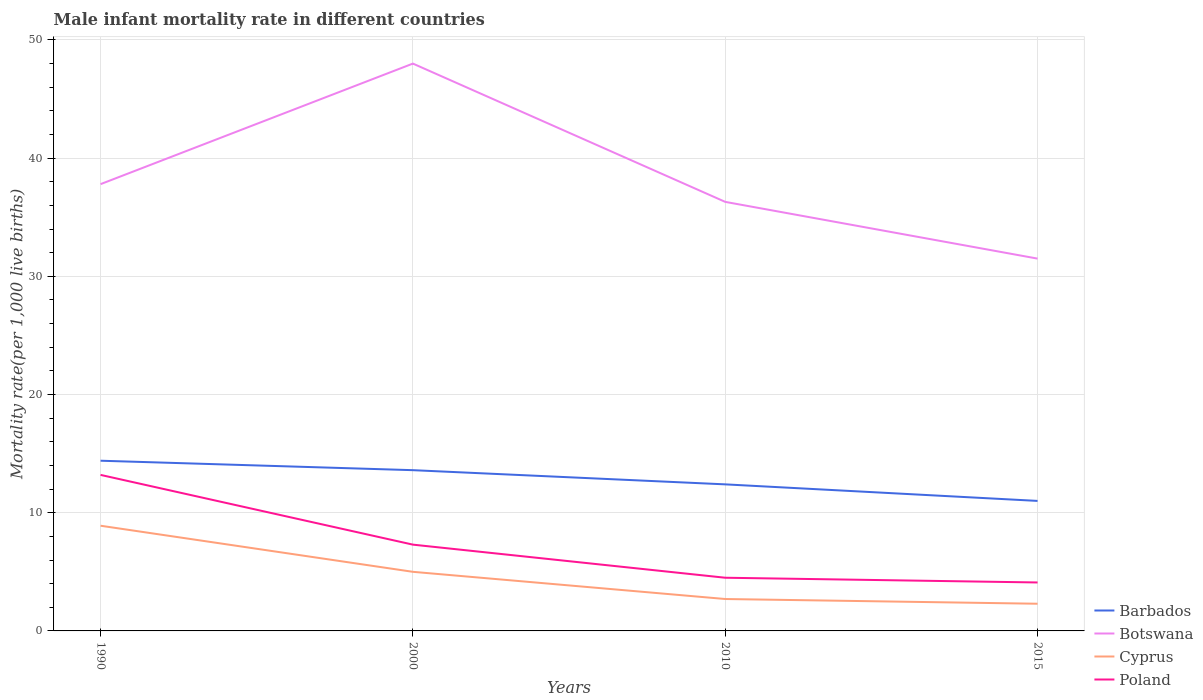How many different coloured lines are there?
Your answer should be very brief. 4. Is the number of lines equal to the number of legend labels?
Make the answer very short. Yes. In which year was the male infant mortality rate in Cyprus maximum?
Keep it short and to the point. 2015. What is the total male infant mortality rate in Botswana in the graph?
Provide a short and direct response. 16.5. How many lines are there?
Your answer should be very brief. 4. How many years are there in the graph?
Provide a short and direct response. 4. What is the difference between two consecutive major ticks on the Y-axis?
Your response must be concise. 10. Does the graph contain any zero values?
Your response must be concise. No. Where does the legend appear in the graph?
Your answer should be very brief. Bottom right. What is the title of the graph?
Your answer should be compact. Male infant mortality rate in different countries. What is the label or title of the Y-axis?
Offer a very short reply. Mortality rate(per 1,0 live births). What is the Mortality rate(per 1,000 live births) of Barbados in 1990?
Offer a very short reply. 14.4. What is the Mortality rate(per 1,000 live births) of Botswana in 1990?
Make the answer very short. 37.8. What is the Mortality rate(per 1,000 live births) in Poland in 1990?
Your answer should be very brief. 13.2. What is the Mortality rate(per 1,000 live births) in Barbados in 2010?
Make the answer very short. 12.4. What is the Mortality rate(per 1,000 live births) of Botswana in 2010?
Your response must be concise. 36.3. What is the Mortality rate(per 1,000 live births) in Cyprus in 2010?
Keep it short and to the point. 2.7. What is the Mortality rate(per 1,000 live births) in Barbados in 2015?
Provide a short and direct response. 11. What is the Mortality rate(per 1,000 live births) in Botswana in 2015?
Make the answer very short. 31.5. What is the Mortality rate(per 1,000 live births) in Cyprus in 2015?
Ensure brevity in your answer.  2.3. What is the Mortality rate(per 1,000 live births) of Poland in 2015?
Provide a short and direct response. 4.1. Across all years, what is the maximum Mortality rate(per 1,000 live births) of Barbados?
Provide a short and direct response. 14.4. Across all years, what is the maximum Mortality rate(per 1,000 live births) of Cyprus?
Provide a short and direct response. 8.9. Across all years, what is the minimum Mortality rate(per 1,000 live births) of Botswana?
Keep it short and to the point. 31.5. Across all years, what is the minimum Mortality rate(per 1,000 live births) of Poland?
Give a very brief answer. 4.1. What is the total Mortality rate(per 1,000 live births) of Barbados in the graph?
Your answer should be compact. 51.4. What is the total Mortality rate(per 1,000 live births) of Botswana in the graph?
Your answer should be very brief. 153.6. What is the total Mortality rate(per 1,000 live births) in Cyprus in the graph?
Your answer should be compact. 18.9. What is the total Mortality rate(per 1,000 live births) in Poland in the graph?
Keep it short and to the point. 29.1. What is the difference between the Mortality rate(per 1,000 live births) in Poland in 1990 and that in 2000?
Your response must be concise. 5.9. What is the difference between the Mortality rate(per 1,000 live births) of Botswana in 1990 and that in 2010?
Your answer should be compact. 1.5. What is the difference between the Mortality rate(per 1,000 live births) of Barbados in 1990 and that in 2015?
Ensure brevity in your answer.  3.4. What is the difference between the Mortality rate(per 1,000 live births) of Cyprus in 1990 and that in 2015?
Your response must be concise. 6.6. What is the difference between the Mortality rate(per 1,000 live births) in Poland in 1990 and that in 2015?
Provide a succinct answer. 9.1. What is the difference between the Mortality rate(per 1,000 live births) of Barbados in 2000 and that in 2010?
Offer a terse response. 1.2. What is the difference between the Mortality rate(per 1,000 live births) of Cyprus in 2000 and that in 2010?
Your response must be concise. 2.3. What is the difference between the Mortality rate(per 1,000 live births) in Poland in 2000 and that in 2010?
Offer a very short reply. 2.8. What is the difference between the Mortality rate(per 1,000 live births) of Barbados in 2000 and that in 2015?
Your answer should be very brief. 2.6. What is the difference between the Mortality rate(per 1,000 live births) in Poland in 2000 and that in 2015?
Offer a very short reply. 3.2. What is the difference between the Mortality rate(per 1,000 live births) in Barbados in 2010 and that in 2015?
Keep it short and to the point. 1.4. What is the difference between the Mortality rate(per 1,000 live births) of Cyprus in 2010 and that in 2015?
Provide a short and direct response. 0.4. What is the difference between the Mortality rate(per 1,000 live births) in Barbados in 1990 and the Mortality rate(per 1,000 live births) in Botswana in 2000?
Offer a terse response. -33.6. What is the difference between the Mortality rate(per 1,000 live births) in Botswana in 1990 and the Mortality rate(per 1,000 live births) in Cyprus in 2000?
Make the answer very short. 32.8. What is the difference between the Mortality rate(per 1,000 live births) in Botswana in 1990 and the Mortality rate(per 1,000 live births) in Poland in 2000?
Provide a short and direct response. 30.5. What is the difference between the Mortality rate(per 1,000 live births) of Barbados in 1990 and the Mortality rate(per 1,000 live births) of Botswana in 2010?
Give a very brief answer. -21.9. What is the difference between the Mortality rate(per 1,000 live births) in Barbados in 1990 and the Mortality rate(per 1,000 live births) in Poland in 2010?
Ensure brevity in your answer.  9.9. What is the difference between the Mortality rate(per 1,000 live births) of Botswana in 1990 and the Mortality rate(per 1,000 live births) of Cyprus in 2010?
Offer a terse response. 35.1. What is the difference between the Mortality rate(per 1,000 live births) in Botswana in 1990 and the Mortality rate(per 1,000 live births) in Poland in 2010?
Keep it short and to the point. 33.3. What is the difference between the Mortality rate(per 1,000 live births) in Cyprus in 1990 and the Mortality rate(per 1,000 live births) in Poland in 2010?
Keep it short and to the point. 4.4. What is the difference between the Mortality rate(per 1,000 live births) in Barbados in 1990 and the Mortality rate(per 1,000 live births) in Botswana in 2015?
Your response must be concise. -17.1. What is the difference between the Mortality rate(per 1,000 live births) in Botswana in 1990 and the Mortality rate(per 1,000 live births) in Cyprus in 2015?
Your response must be concise. 35.5. What is the difference between the Mortality rate(per 1,000 live births) of Botswana in 1990 and the Mortality rate(per 1,000 live births) of Poland in 2015?
Keep it short and to the point. 33.7. What is the difference between the Mortality rate(per 1,000 live births) of Barbados in 2000 and the Mortality rate(per 1,000 live births) of Botswana in 2010?
Ensure brevity in your answer.  -22.7. What is the difference between the Mortality rate(per 1,000 live births) of Barbados in 2000 and the Mortality rate(per 1,000 live births) of Cyprus in 2010?
Offer a terse response. 10.9. What is the difference between the Mortality rate(per 1,000 live births) of Barbados in 2000 and the Mortality rate(per 1,000 live births) of Poland in 2010?
Make the answer very short. 9.1. What is the difference between the Mortality rate(per 1,000 live births) in Botswana in 2000 and the Mortality rate(per 1,000 live births) in Cyprus in 2010?
Offer a terse response. 45.3. What is the difference between the Mortality rate(per 1,000 live births) of Botswana in 2000 and the Mortality rate(per 1,000 live births) of Poland in 2010?
Your answer should be compact. 43.5. What is the difference between the Mortality rate(per 1,000 live births) of Cyprus in 2000 and the Mortality rate(per 1,000 live births) of Poland in 2010?
Your answer should be compact. 0.5. What is the difference between the Mortality rate(per 1,000 live births) in Barbados in 2000 and the Mortality rate(per 1,000 live births) in Botswana in 2015?
Your answer should be compact. -17.9. What is the difference between the Mortality rate(per 1,000 live births) of Barbados in 2000 and the Mortality rate(per 1,000 live births) of Cyprus in 2015?
Your answer should be compact. 11.3. What is the difference between the Mortality rate(per 1,000 live births) in Botswana in 2000 and the Mortality rate(per 1,000 live births) in Cyprus in 2015?
Your answer should be very brief. 45.7. What is the difference between the Mortality rate(per 1,000 live births) of Botswana in 2000 and the Mortality rate(per 1,000 live births) of Poland in 2015?
Your response must be concise. 43.9. What is the difference between the Mortality rate(per 1,000 live births) of Barbados in 2010 and the Mortality rate(per 1,000 live births) of Botswana in 2015?
Provide a short and direct response. -19.1. What is the difference between the Mortality rate(per 1,000 live births) in Barbados in 2010 and the Mortality rate(per 1,000 live births) in Poland in 2015?
Offer a terse response. 8.3. What is the difference between the Mortality rate(per 1,000 live births) in Botswana in 2010 and the Mortality rate(per 1,000 live births) in Poland in 2015?
Make the answer very short. 32.2. What is the average Mortality rate(per 1,000 live births) of Barbados per year?
Offer a very short reply. 12.85. What is the average Mortality rate(per 1,000 live births) in Botswana per year?
Ensure brevity in your answer.  38.4. What is the average Mortality rate(per 1,000 live births) of Cyprus per year?
Ensure brevity in your answer.  4.72. What is the average Mortality rate(per 1,000 live births) in Poland per year?
Make the answer very short. 7.28. In the year 1990, what is the difference between the Mortality rate(per 1,000 live births) in Barbados and Mortality rate(per 1,000 live births) in Botswana?
Your response must be concise. -23.4. In the year 1990, what is the difference between the Mortality rate(per 1,000 live births) of Barbados and Mortality rate(per 1,000 live births) of Poland?
Make the answer very short. 1.2. In the year 1990, what is the difference between the Mortality rate(per 1,000 live births) of Botswana and Mortality rate(per 1,000 live births) of Cyprus?
Give a very brief answer. 28.9. In the year 1990, what is the difference between the Mortality rate(per 1,000 live births) of Botswana and Mortality rate(per 1,000 live births) of Poland?
Your answer should be very brief. 24.6. In the year 2000, what is the difference between the Mortality rate(per 1,000 live births) in Barbados and Mortality rate(per 1,000 live births) in Botswana?
Your answer should be compact. -34.4. In the year 2000, what is the difference between the Mortality rate(per 1,000 live births) of Barbados and Mortality rate(per 1,000 live births) of Poland?
Offer a very short reply. 6.3. In the year 2000, what is the difference between the Mortality rate(per 1,000 live births) in Botswana and Mortality rate(per 1,000 live births) in Cyprus?
Make the answer very short. 43. In the year 2000, what is the difference between the Mortality rate(per 1,000 live births) in Botswana and Mortality rate(per 1,000 live births) in Poland?
Provide a short and direct response. 40.7. In the year 2010, what is the difference between the Mortality rate(per 1,000 live births) of Barbados and Mortality rate(per 1,000 live births) of Botswana?
Make the answer very short. -23.9. In the year 2010, what is the difference between the Mortality rate(per 1,000 live births) of Barbados and Mortality rate(per 1,000 live births) of Poland?
Offer a very short reply. 7.9. In the year 2010, what is the difference between the Mortality rate(per 1,000 live births) in Botswana and Mortality rate(per 1,000 live births) in Cyprus?
Offer a terse response. 33.6. In the year 2010, what is the difference between the Mortality rate(per 1,000 live births) of Botswana and Mortality rate(per 1,000 live births) of Poland?
Make the answer very short. 31.8. In the year 2010, what is the difference between the Mortality rate(per 1,000 live births) of Cyprus and Mortality rate(per 1,000 live births) of Poland?
Your answer should be very brief. -1.8. In the year 2015, what is the difference between the Mortality rate(per 1,000 live births) in Barbados and Mortality rate(per 1,000 live births) in Botswana?
Provide a succinct answer. -20.5. In the year 2015, what is the difference between the Mortality rate(per 1,000 live births) in Barbados and Mortality rate(per 1,000 live births) in Cyprus?
Provide a succinct answer. 8.7. In the year 2015, what is the difference between the Mortality rate(per 1,000 live births) of Botswana and Mortality rate(per 1,000 live births) of Cyprus?
Your response must be concise. 29.2. In the year 2015, what is the difference between the Mortality rate(per 1,000 live births) of Botswana and Mortality rate(per 1,000 live births) of Poland?
Your answer should be very brief. 27.4. What is the ratio of the Mortality rate(per 1,000 live births) of Barbados in 1990 to that in 2000?
Make the answer very short. 1.06. What is the ratio of the Mortality rate(per 1,000 live births) of Botswana in 1990 to that in 2000?
Provide a succinct answer. 0.79. What is the ratio of the Mortality rate(per 1,000 live births) of Cyprus in 1990 to that in 2000?
Offer a terse response. 1.78. What is the ratio of the Mortality rate(per 1,000 live births) of Poland in 1990 to that in 2000?
Your response must be concise. 1.81. What is the ratio of the Mortality rate(per 1,000 live births) in Barbados in 1990 to that in 2010?
Offer a very short reply. 1.16. What is the ratio of the Mortality rate(per 1,000 live births) in Botswana in 1990 to that in 2010?
Make the answer very short. 1.04. What is the ratio of the Mortality rate(per 1,000 live births) of Cyprus in 1990 to that in 2010?
Your answer should be compact. 3.3. What is the ratio of the Mortality rate(per 1,000 live births) of Poland in 1990 to that in 2010?
Offer a terse response. 2.93. What is the ratio of the Mortality rate(per 1,000 live births) of Barbados in 1990 to that in 2015?
Your response must be concise. 1.31. What is the ratio of the Mortality rate(per 1,000 live births) of Cyprus in 1990 to that in 2015?
Your answer should be very brief. 3.87. What is the ratio of the Mortality rate(per 1,000 live births) of Poland in 1990 to that in 2015?
Ensure brevity in your answer.  3.22. What is the ratio of the Mortality rate(per 1,000 live births) of Barbados in 2000 to that in 2010?
Your answer should be very brief. 1.1. What is the ratio of the Mortality rate(per 1,000 live births) of Botswana in 2000 to that in 2010?
Offer a very short reply. 1.32. What is the ratio of the Mortality rate(per 1,000 live births) of Cyprus in 2000 to that in 2010?
Make the answer very short. 1.85. What is the ratio of the Mortality rate(per 1,000 live births) of Poland in 2000 to that in 2010?
Give a very brief answer. 1.62. What is the ratio of the Mortality rate(per 1,000 live births) of Barbados in 2000 to that in 2015?
Your answer should be compact. 1.24. What is the ratio of the Mortality rate(per 1,000 live births) in Botswana in 2000 to that in 2015?
Offer a terse response. 1.52. What is the ratio of the Mortality rate(per 1,000 live births) of Cyprus in 2000 to that in 2015?
Give a very brief answer. 2.17. What is the ratio of the Mortality rate(per 1,000 live births) in Poland in 2000 to that in 2015?
Provide a succinct answer. 1.78. What is the ratio of the Mortality rate(per 1,000 live births) in Barbados in 2010 to that in 2015?
Give a very brief answer. 1.13. What is the ratio of the Mortality rate(per 1,000 live births) of Botswana in 2010 to that in 2015?
Keep it short and to the point. 1.15. What is the ratio of the Mortality rate(per 1,000 live births) of Cyprus in 2010 to that in 2015?
Make the answer very short. 1.17. What is the ratio of the Mortality rate(per 1,000 live births) in Poland in 2010 to that in 2015?
Provide a succinct answer. 1.1. What is the difference between the highest and the second highest Mortality rate(per 1,000 live births) of Cyprus?
Make the answer very short. 3.9. What is the difference between the highest and the second highest Mortality rate(per 1,000 live births) of Poland?
Your answer should be very brief. 5.9. What is the difference between the highest and the lowest Mortality rate(per 1,000 live births) in Barbados?
Your response must be concise. 3.4. What is the difference between the highest and the lowest Mortality rate(per 1,000 live births) in Poland?
Ensure brevity in your answer.  9.1. 